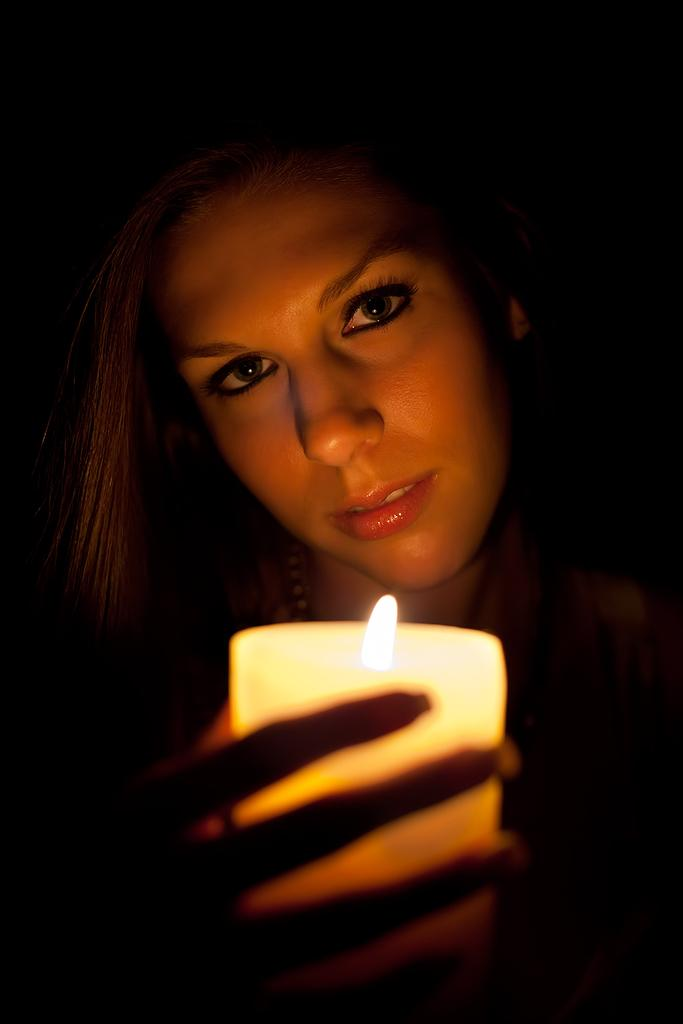Who is in the image? There is a woman in the image. What is the woman doing in the image? The woman is smiling and holding a candle light. What can be observed about the background of the image? The background of the image is dark in color. How many girls are present in the image? There is only one woman in the image, not a group of girls. What type of reward can be seen in the image? There is no reward visible in the image; it features a woman holding a candle light. 